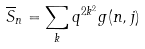Convert formula to latex. <formula><loc_0><loc_0><loc_500><loc_500>\overline { S } _ { n } & = \sum _ { k } q ^ { 2 k ^ { 2 } } g ( n , j )</formula> 